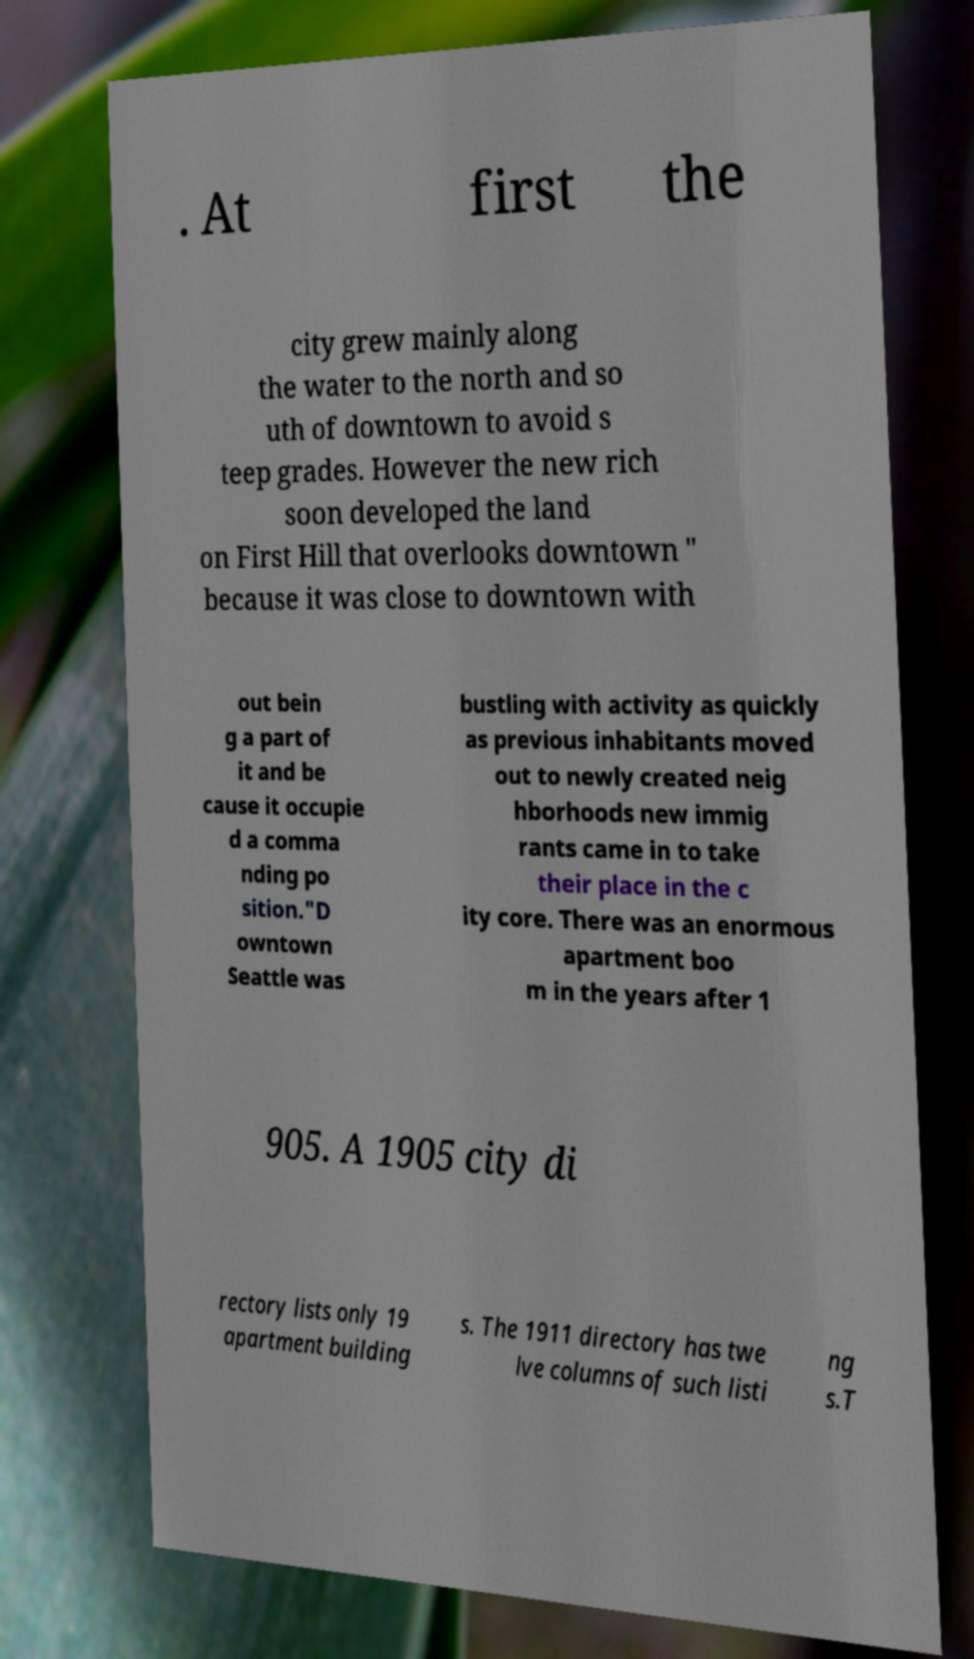I need the written content from this picture converted into text. Can you do that? . At first the city grew mainly along the water to the north and so uth of downtown to avoid s teep grades. However the new rich soon developed the land on First Hill that overlooks downtown " because it was close to downtown with out bein g a part of it and be cause it occupie d a comma nding po sition."D owntown Seattle was bustling with activity as quickly as previous inhabitants moved out to newly created neig hborhoods new immig rants came in to take their place in the c ity core. There was an enormous apartment boo m in the years after 1 905. A 1905 city di rectory lists only 19 apartment building s. The 1911 directory has twe lve columns of such listi ng s.T 